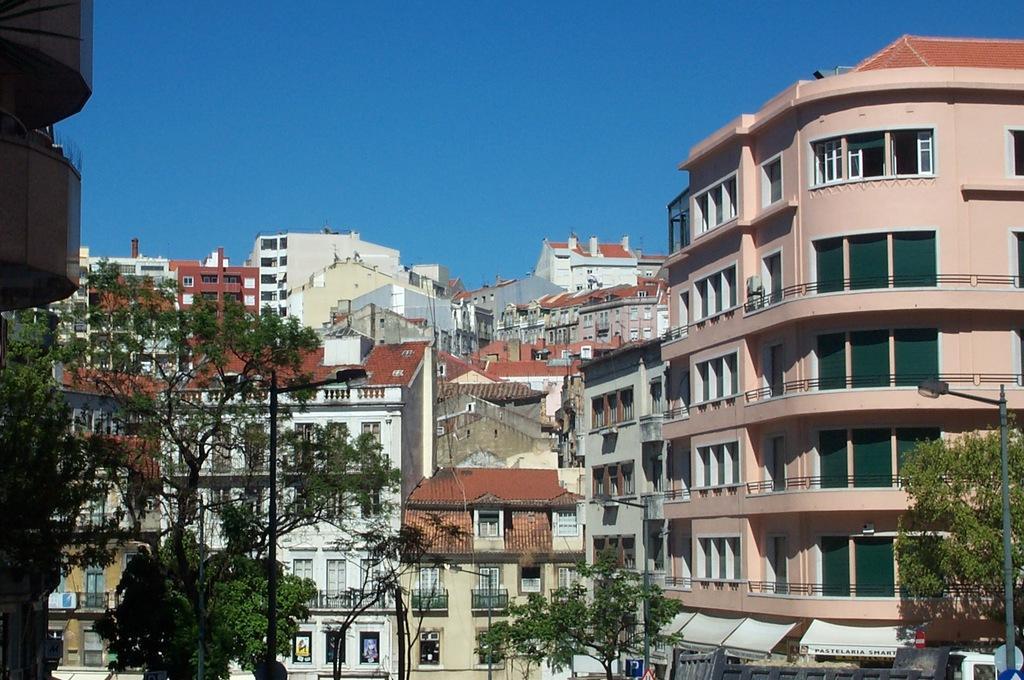Describe this image in one or two sentences. In this image in the middle, there are many buildings, trees, electric poles, street lights and windows. At the bottom there are tents. At the top there is sky. 